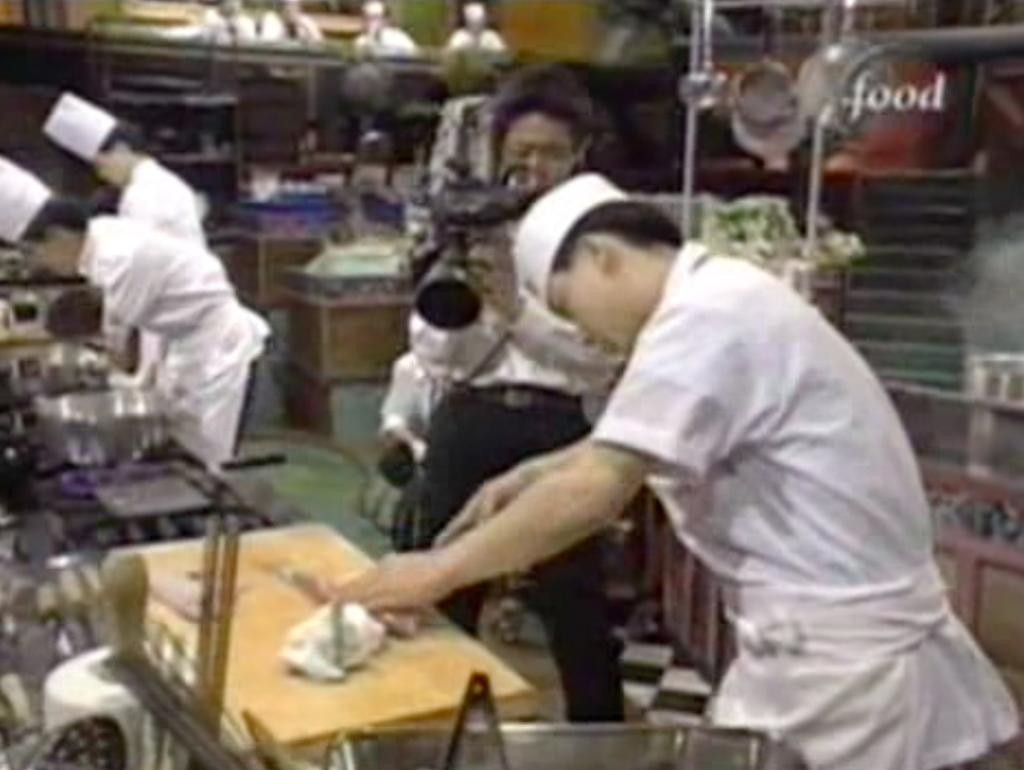What type of room is shown in the image? The image depicts a kitchen. What are the people in the kitchen doing? People are working in the kitchen. Is there anyone observing or documenting the activities in the kitchen? Yes, there is a person recording the people working in the kitchen. What type of animals can be seen in the zoo in the image? There is no zoo present in the image; it depicts a kitchen. What type of jewelry is the person wearing in the image? There is no mention of jewelry in the image, as it focuses on the kitchen and the people working in it. 